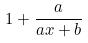Convert formula to latex. <formula><loc_0><loc_0><loc_500><loc_500>1 + \frac { a } { a x + b }</formula> 